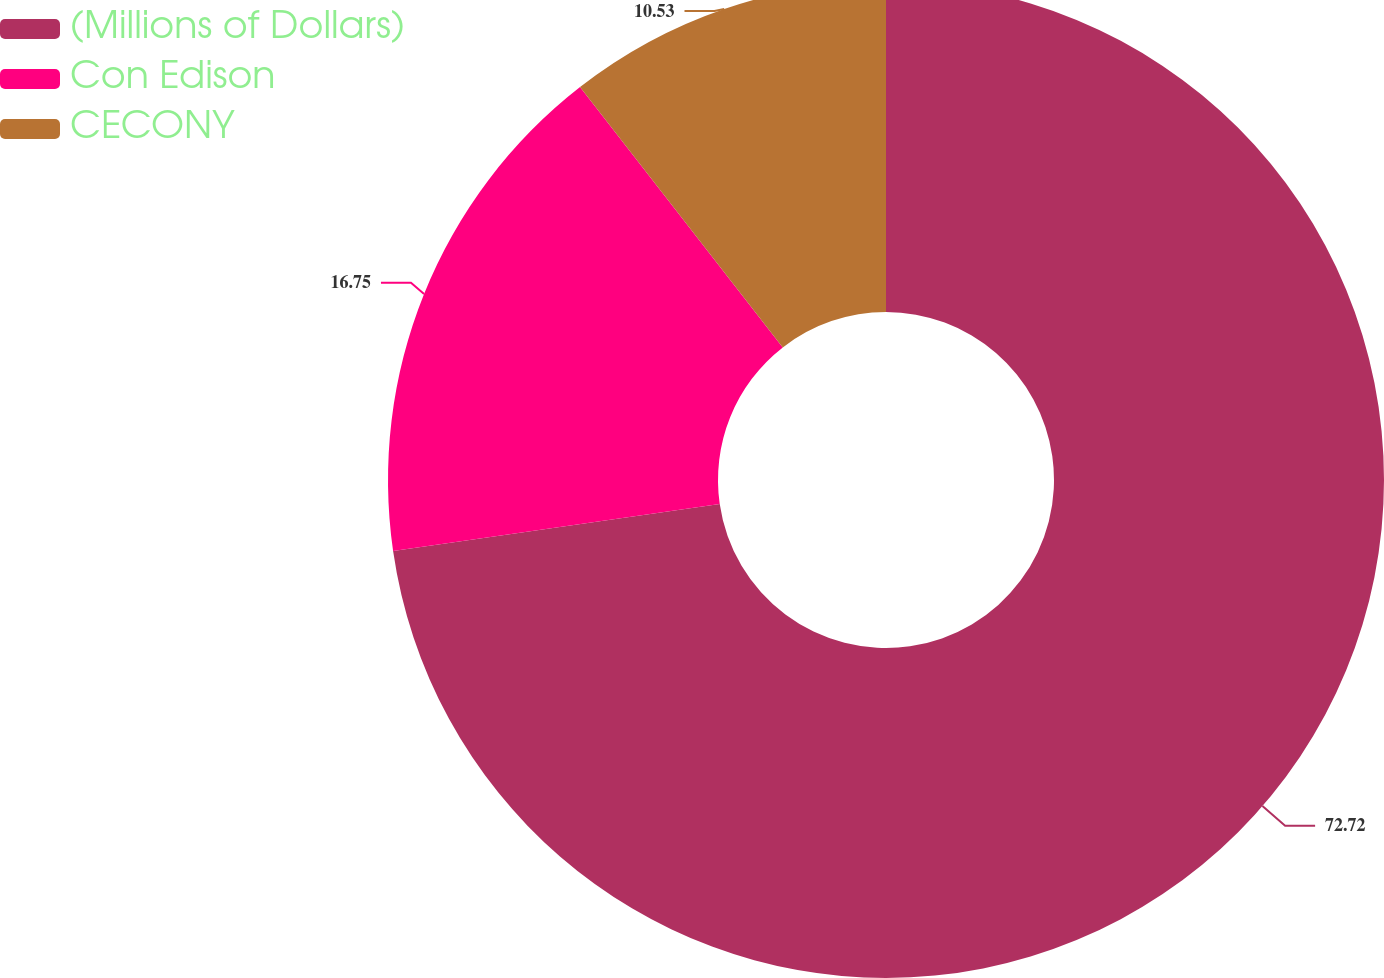Convert chart. <chart><loc_0><loc_0><loc_500><loc_500><pie_chart><fcel>(Millions of Dollars)<fcel>Con Edison<fcel>CECONY<nl><fcel>72.72%<fcel>16.75%<fcel>10.53%<nl></chart> 